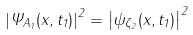<formula> <loc_0><loc_0><loc_500><loc_500>\ \left | \Psi _ { A _ { 1 } } ( x , t _ { 1 } ) \right | ^ { 2 } = \left | \psi _ { \zeta _ { 2 } } ( x , t _ { 1 } ) \right | ^ { 2 }</formula> 